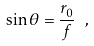Convert formula to latex. <formula><loc_0><loc_0><loc_500><loc_500>\sin \theta = \frac { r _ { 0 } } { f } \ ,</formula> 